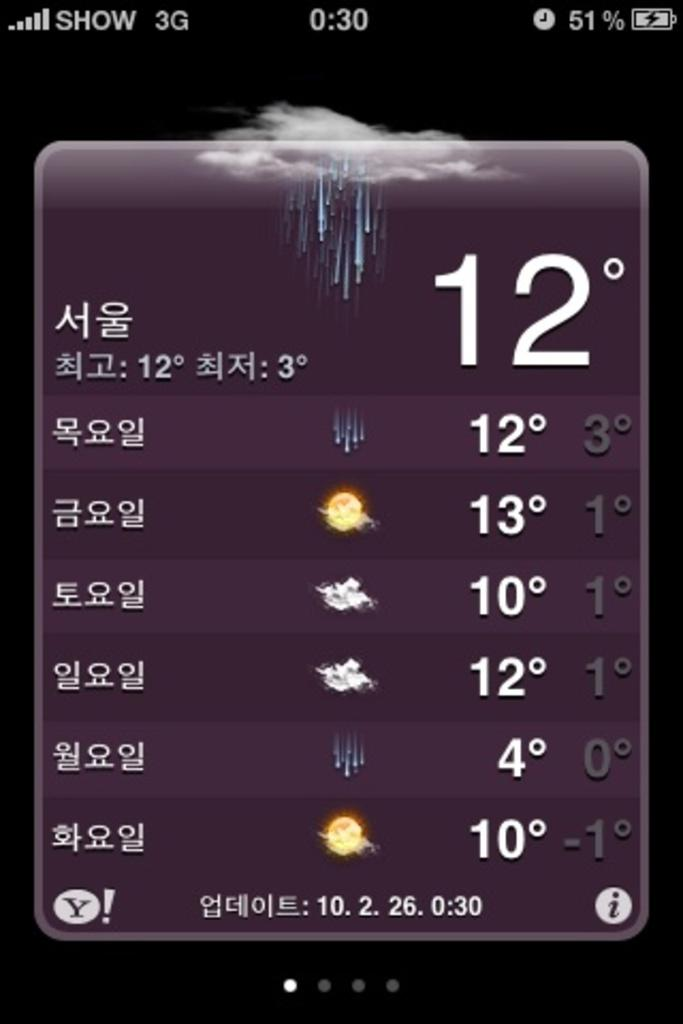<image>
Summarize the visual content of the image. A weather post that says show 3g in the corner. 